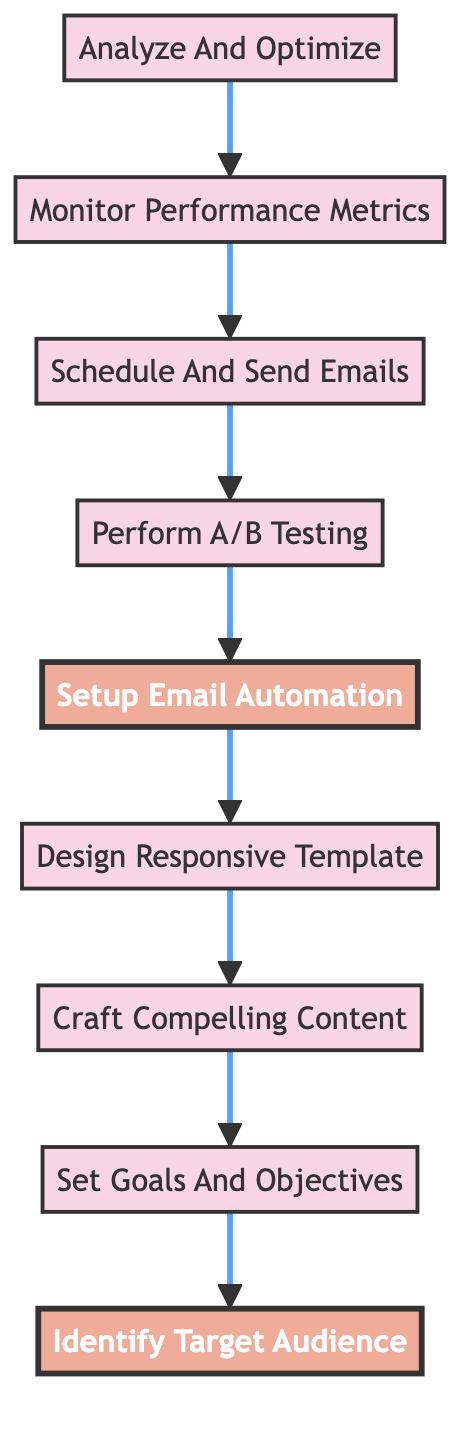What is the first step in the email marketing campaign execution? The diagram starts from the bottom and the first step (at the bottom) is "Identify Target Audience."
Answer: Identify Target Audience How many total steps are in the email marketing campaign execution? Counting the nodes in the diagram, there are eight steps from "Identify Target Audience" to "Analyze and Optimize."
Answer: 8 Which step comes directly after setting the goals and objectives? In the flow, after "Set Goals and Objectives," the next step is "Craft Compelling Content."
Answer: Craft Compelling Content What is the last step in the execution process? The flowchart indicates that the last step (at the top) is "Analyze and Optimize."
Answer: Analyze And Optimize Which two steps are highlighted in the diagram? The highlighted nodes are "Identify Target Audience" and "Setup Email Automation," marked by distinct colors.
Answer: Identify Target Audience, Setup Email Automation After monitoring performance metrics, what is the next action to take? Following "Monitor Performance Metrics," the next action is to "Schedule And Send Emails."
Answer: Schedule And Send Emails What is the step that immediately precedes the design of the responsive template? Looking at the flow, the step before "Design Responsive Template" is "Setup Email Automation."
Answer: Setup Email Automation Which step involves creating engaging and relevant email content? The step titled "Craft Compelling Content" is focused on creating engaging and relevant email content as per the flow.
Answer: Craft Compelling Content What action follows after A/B testing in the campaign execution? After "Perform A/B Testing," the subsequent step is "Setup Email Automation."
Answer: Setup Email Automation 